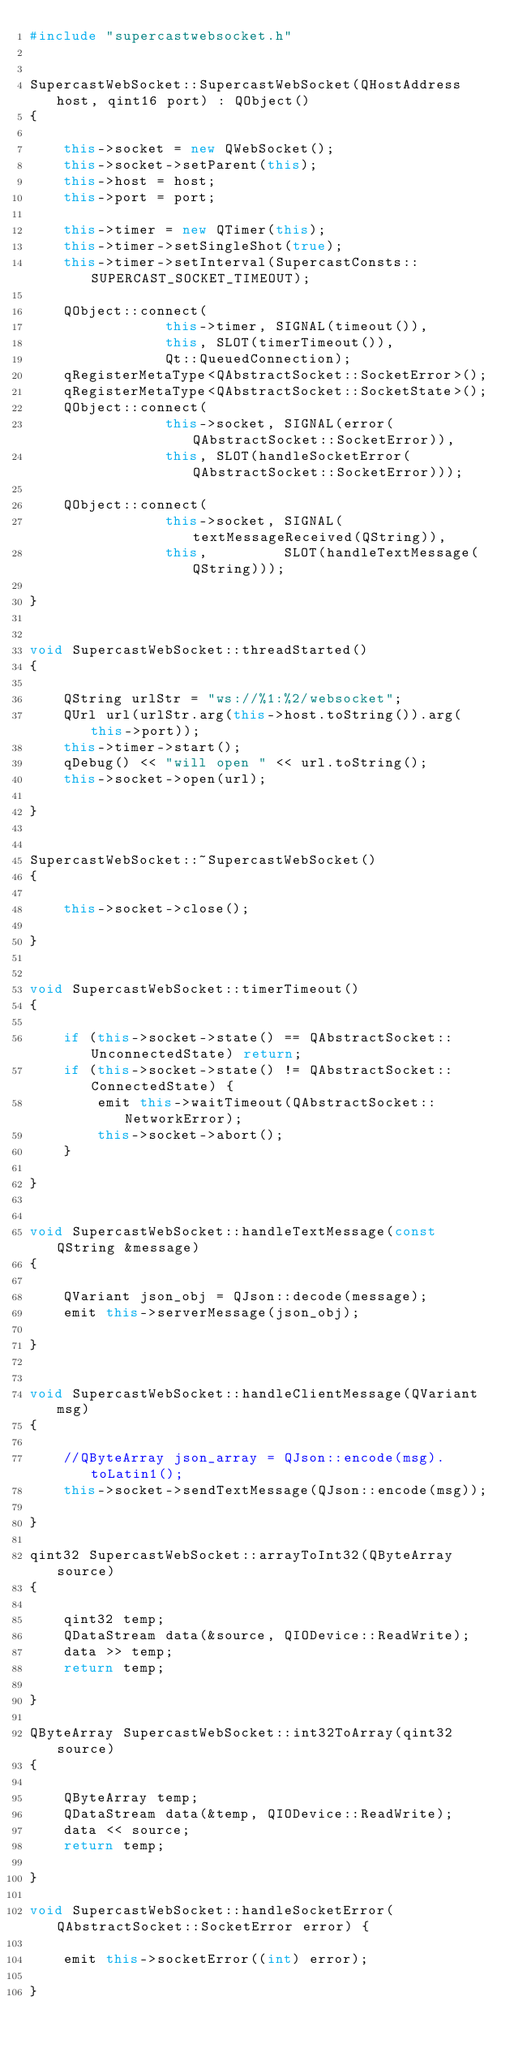<code> <loc_0><loc_0><loc_500><loc_500><_C++_>#include "supercastwebsocket.h"


SupercastWebSocket::SupercastWebSocket(QHostAddress host, qint16 port) : QObject()
{

    this->socket = new QWebSocket();
    this->socket->setParent(this);
    this->host = host;
    this->port = port;

    this->timer = new QTimer(this);
    this->timer->setSingleShot(true);
    this->timer->setInterval(SupercastConsts::SUPERCAST_SOCKET_TIMEOUT);

    QObject::connect(
                this->timer, SIGNAL(timeout()),
                this, SLOT(timerTimeout()),
                Qt::QueuedConnection);
    qRegisterMetaType<QAbstractSocket::SocketError>();
    qRegisterMetaType<QAbstractSocket::SocketState>();
    QObject::connect(
                this->socket, SIGNAL(error(QAbstractSocket::SocketError)),
                this, SLOT(handleSocketError(QAbstractSocket::SocketError)));

    QObject::connect(
                this->socket, SIGNAL(textMessageReceived(QString)),
                this,         SLOT(handleTextMessage(QString)));

}


void SupercastWebSocket::threadStarted()
{

    QString urlStr = "ws://%1:%2/websocket";
    QUrl url(urlStr.arg(this->host.toString()).arg(this->port));
    this->timer->start();
    qDebug() << "will open " << url.toString();
    this->socket->open(url);

}


SupercastWebSocket::~SupercastWebSocket()
{

    this->socket->close();

}


void SupercastWebSocket::timerTimeout()
{

    if (this->socket->state() == QAbstractSocket::UnconnectedState) return;
    if (this->socket->state() != QAbstractSocket::ConnectedState) {
        emit this->waitTimeout(QAbstractSocket::NetworkError);
        this->socket->abort();
    }

}


void SupercastWebSocket::handleTextMessage(const QString &message)
{

    QVariant json_obj = QJson::decode(message);
    emit this->serverMessage(json_obj);

}


void SupercastWebSocket::handleClientMessage(QVariant msg)
{

    //QByteArray json_array = QJson::encode(msg).toLatin1();
    this->socket->sendTextMessage(QJson::encode(msg));

}

qint32 SupercastWebSocket::arrayToInt32(QByteArray source)
{

    qint32 temp;
    QDataStream data(&source, QIODevice::ReadWrite);
    data >> temp;
    return temp;

}

QByteArray SupercastWebSocket::int32ToArray(qint32 source)
{

    QByteArray temp;
    QDataStream data(&temp, QIODevice::ReadWrite);
    data << source;
    return temp;

}

void SupercastWebSocket::handleSocketError(QAbstractSocket::SocketError error) {

    emit this->socketError((int) error);

}


</code> 